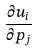Convert formula to latex. <formula><loc_0><loc_0><loc_500><loc_500>\frac { \partial u _ { i } } { \partial p _ { j } }</formula> 